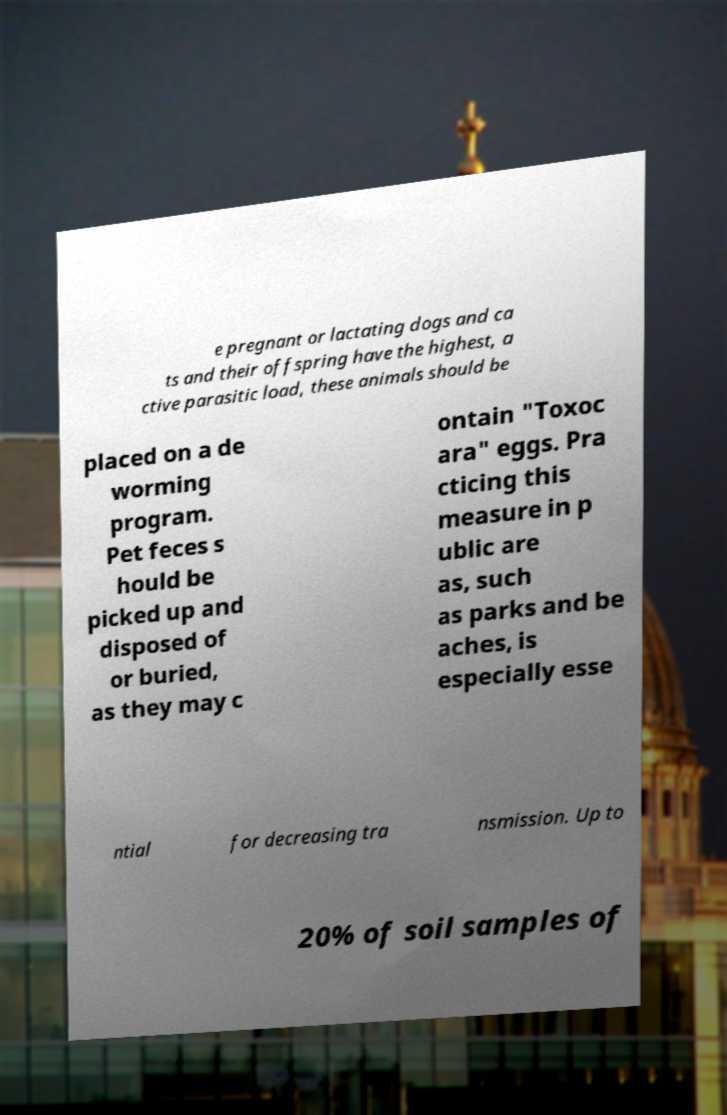Could you assist in decoding the text presented in this image and type it out clearly? e pregnant or lactating dogs and ca ts and their offspring have the highest, a ctive parasitic load, these animals should be placed on a de worming program. Pet feces s hould be picked up and disposed of or buried, as they may c ontain "Toxoc ara" eggs. Pra cticing this measure in p ublic are as, such as parks and be aches, is especially esse ntial for decreasing tra nsmission. Up to 20% of soil samples of 